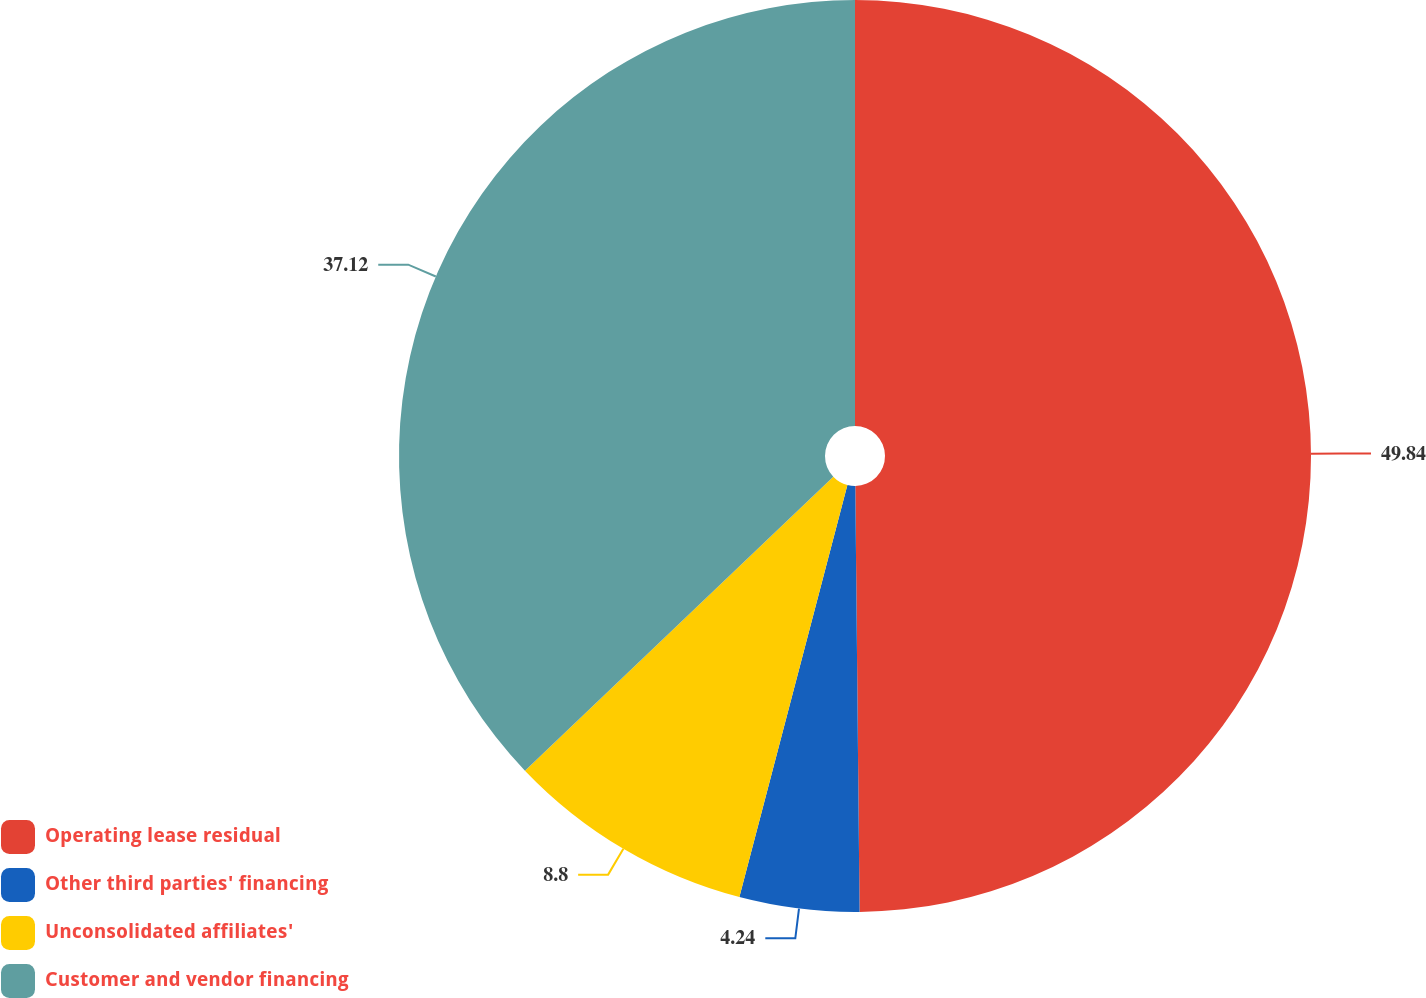Convert chart. <chart><loc_0><loc_0><loc_500><loc_500><pie_chart><fcel>Operating lease residual<fcel>Other third parties' financing<fcel>Unconsolidated affiliates'<fcel>Customer and vendor financing<nl><fcel>49.84%<fcel>4.24%<fcel>8.8%<fcel>37.12%<nl></chart> 